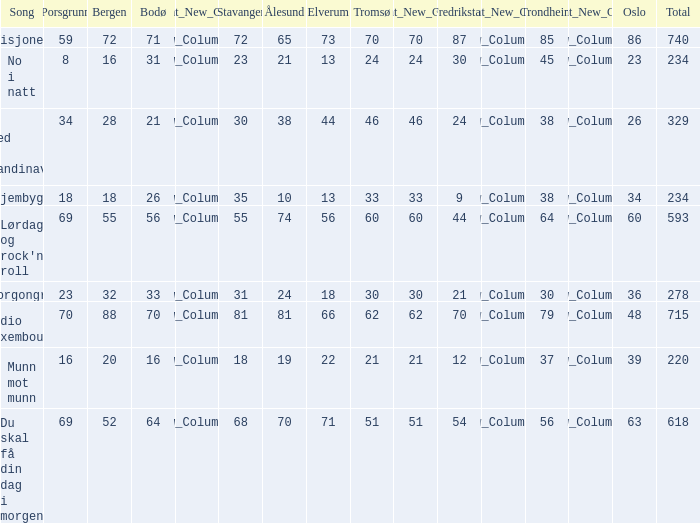How many elverum can be found at a place in scandinavia? 1.0. 